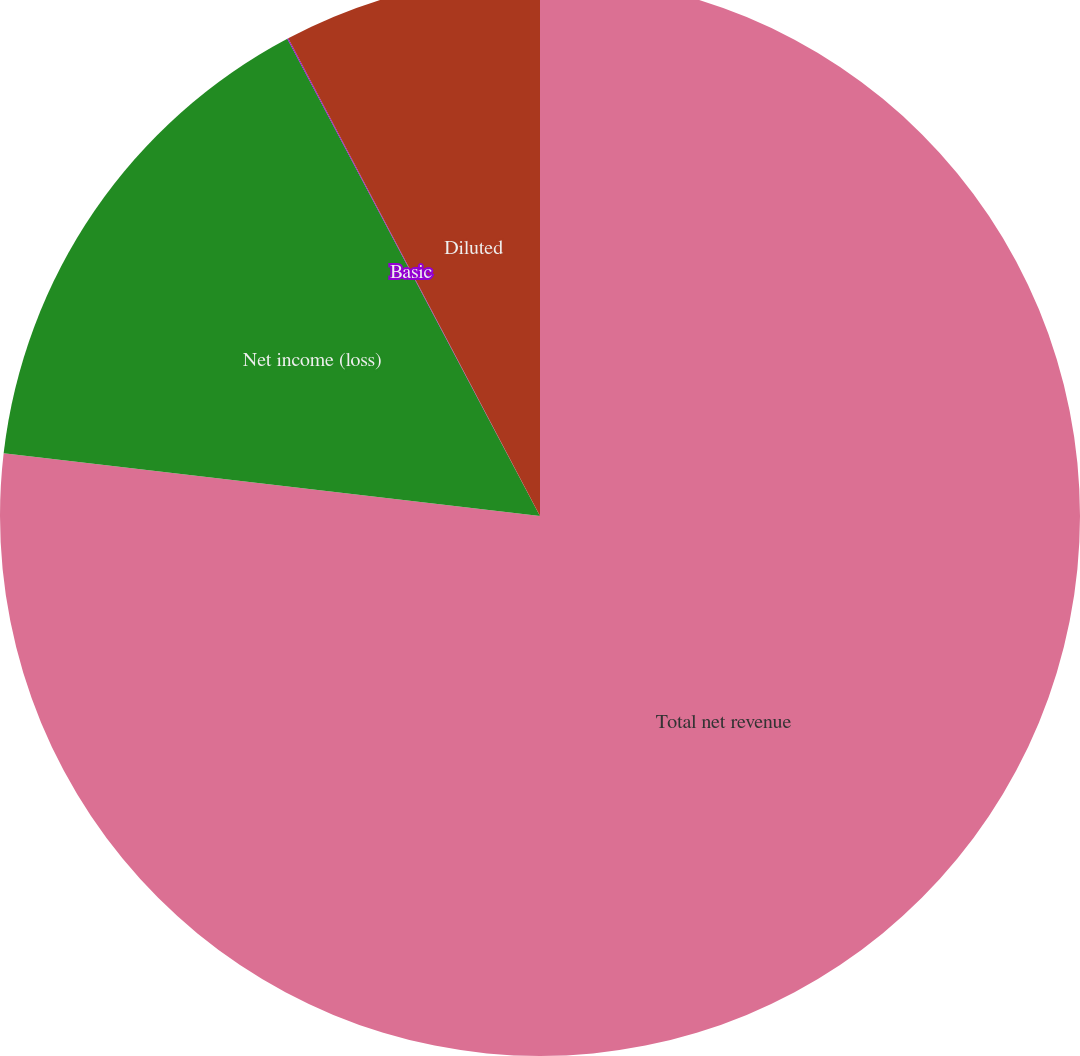Convert chart to OTSL. <chart><loc_0><loc_0><loc_500><loc_500><pie_chart><fcel>Total net revenue<fcel>Net income (loss)<fcel>Basic<fcel>Diluted<nl><fcel>76.85%<fcel>15.4%<fcel>0.03%<fcel>7.72%<nl></chart> 